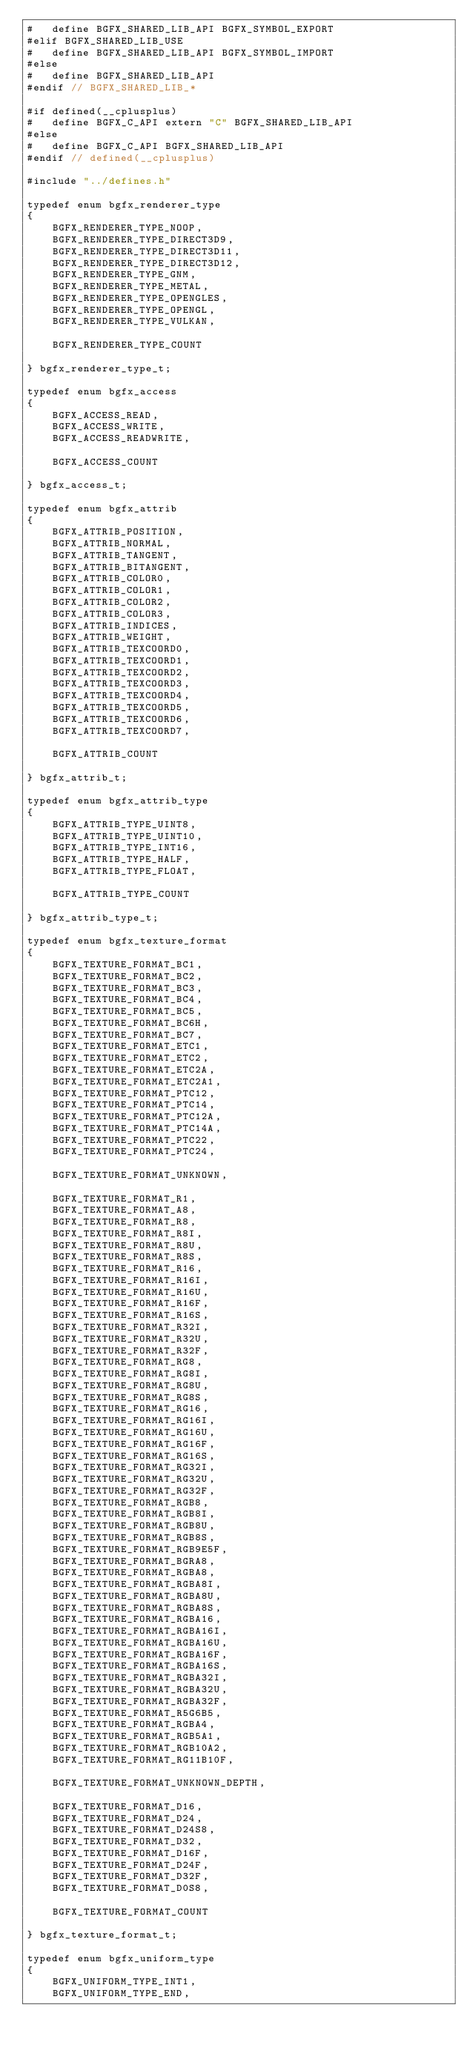Convert code to text. <code><loc_0><loc_0><loc_500><loc_500><_C_>#   define BGFX_SHARED_LIB_API BGFX_SYMBOL_EXPORT
#elif BGFX_SHARED_LIB_USE
#   define BGFX_SHARED_LIB_API BGFX_SYMBOL_IMPORT
#else
#   define BGFX_SHARED_LIB_API
#endif // BGFX_SHARED_LIB_*

#if defined(__cplusplus)
#   define BGFX_C_API extern "C" BGFX_SHARED_LIB_API
#else
#   define BGFX_C_API BGFX_SHARED_LIB_API
#endif // defined(__cplusplus)

#include "../defines.h"

typedef enum bgfx_renderer_type
{
    BGFX_RENDERER_TYPE_NOOP,
    BGFX_RENDERER_TYPE_DIRECT3D9,
    BGFX_RENDERER_TYPE_DIRECT3D11,
    BGFX_RENDERER_TYPE_DIRECT3D12,
    BGFX_RENDERER_TYPE_GNM,
    BGFX_RENDERER_TYPE_METAL,
    BGFX_RENDERER_TYPE_OPENGLES,
    BGFX_RENDERER_TYPE_OPENGL,
    BGFX_RENDERER_TYPE_VULKAN,

    BGFX_RENDERER_TYPE_COUNT

} bgfx_renderer_type_t;

typedef enum bgfx_access
{
    BGFX_ACCESS_READ,
    BGFX_ACCESS_WRITE,
    BGFX_ACCESS_READWRITE,

    BGFX_ACCESS_COUNT

} bgfx_access_t;

typedef enum bgfx_attrib
{
    BGFX_ATTRIB_POSITION,
    BGFX_ATTRIB_NORMAL,
    BGFX_ATTRIB_TANGENT,
    BGFX_ATTRIB_BITANGENT,
    BGFX_ATTRIB_COLOR0,
    BGFX_ATTRIB_COLOR1,
    BGFX_ATTRIB_COLOR2,
    BGFX_ATTRIB_COLOR3,
    BGFX_ATTRIB_INDICES,
    BGFX_ATTRIB_WEIGHT,
    BGFX_ATTRIB_TEXCOORD0,
    BGFX_ATTRIB_TEXCOORD1,
    BGFX_ATTRIB_TEXCOORD2,
    BGFX_ATTRIB_TEXCOORD3,
    BGFX_ATTRIB_TEXCOORD4,
    BGFX_ATTRIB_TEXCOORD5,
    BGFX_ATTRIB_TEXCOORD6,
    BGFX_ATTRIB_TEXCOORD7,

    BGFX_ATTRIB_COUNT

} bgfx_attrib_t;

typedef enum bgfx_attrib_type
{
    BGFX_ATTRIB_TYPE_UINT8,
    BGFX_ATTRIB_TYPE_UINT10,
    BGFX_ATTRIB_TYPE_INT16,
    BGFX_ATTRIB_TYPE_HALF,
    BGFX_ATTRIB_TYPE_FLOAT,

    BGFX_ATTRIB_TYPE_COUNT

} bgfx_attrib_type_t;

typedef enum bgfx_texture_format
{
    BGFX_TEXTURE_FORMAT_BC1,
    BGFX_TEXTURE_FORMAT_BC2,
    BGFX_TEXTURE_FORMAT_BC3,
    BGFX_TEXTURE_FORMAT_BC4,
    BGFX_TEXTURE_FORMAT_BC5,
    BGFX_TEXTURE_FORMAT_BC6H,
    BGFX_TEXTURE_FORMAT_BC7,
    BGFX_TEXTURE_FORMAT_ETC1,
    BGFX_TEXTURE_FORMAT_ETC2,
    BGFX_TEXTURE_FORMAT_ETC2A,
    BGFX_TEXTURE_FORMAT_ETC2A1,
    BGFX_TEXTURE_FORMAT_PTC12,
    BGFX_TEXTURE_FORMAT_PTC14,
    BGFX_TEXTURE_FORMAT_PTC12A,
    BGFX_TEXTURE_FORMAT_PTC14A,
    BGFX_TEXTURE_FORMAT_PTC22,
    BGFX_TEXTURE_FORMAT_PTC24,

    BGFX_TEXTURE_FORMAT_UNKNOWN,

    BGFX_TEXTURE_FORMAT_R1,
    BGFX_TEXTURE_FORMAT_A8,
    BGFX_TEXTURE_FORMAT_R8,
    BGFX_TEXTURE_FORMAT_R8I,
    BGFX_TEXTURE_FORMAT_R8U,
    BGFX_TEXTURE_FORMAT_R8S,
    BGFX_TEXTURE_FORMAT_R16,
    BGFX_TEXTURE_FORMAT_R16I,
    BGFX_TEXTURE_FORMAT_R16U,
    BGFX_TEXTURE_FORMAT_R16F,
    BGFX_TEXTURE_FORMAT_R16S,
    BGFX_TEXTURE_FORMAT_R32I,
    BGFX_TEXTURE_FORMAT_R32U,
    BGFX_TEXTURE_FORMAT_R32F,
    BGFX_TEXTURE_FORMAT_RG8,
    BGFX_TEXTURE_FORMAT_RG8I,
    BGFX_TEXTURE_FORMAT_RG8U,
    BGFX_TEXTURE_FORMAT_RG8S,
    BGFX_TEXTURE_FORMAT_RG16,
    BGFX_TEXTURE_FORMAT_RG16I,
    BGFX_TEXTURE_FORMAT_RG16U,
    BGFX_TEXTURE_FORMAT_RG16F,
    BGFX_TEXTURE_FORMAT_RG16S,
    BGFX_TEXTURE_FORMAT_RG32I,
    BGFX_TEXTURE_FORMAT_RG32U,
    BGFX_TEXTURE_FORMAT_RG32F,
    BGFX_TEXTURE_FORMAT_RGB8,
    BGFX_TEXTURE_FORMAT_RGB8I,
    BGFX_TEXTURE_FORMAT_RGB8U,
    BGFX_TEXTURE_FORMAT_RGB8S,
    BGFX_TEXTURE_FORMAT_RGB9E5F,
    BGFX_TEXTURE_FORMAT_BGRA8,
    BGFX_TEXTURE_FORMAT_RGBA8,
    BGFX_TEXTURE_FORMAT_RGBA8I,
    BGFX_TEXTURE_FORMAT_RGBA8U,
    BGFX_TEXTURE_FORMAT_RGBA8S,
    BGFX_TEXTURE_FORMAT_RGBA16,
    BGFX_TEXTURE_FORMAT_RGBA16I,
    BGFX_TEXTURE_FORMAT_RGBA16U,
    BGFX_TEXTURE_FORMAT_RGBA16F,
    BGFX_TEXTURE_FORMAT_RGBA16S,
    BGFX_TEXTURE_FORMAT_RGBA32I,
    BGFX_TEXTURE_FORMAT_RGBA32U,
    BGFX_TEXTURE_FORMAT_RGBA32F,
    BGFX_TEXTURE_FORMAT_R5G6B5,
    BGFX_TEXTURE_FORMAT_RGBA4,
    BGFX_TEXTURE_FORMAT_RGB5A1,
    BGFX_TEXTURE_FORMAT_RGB10A2,
    BGFX_TEXTURE_FORMAT_RG11B10F,

    BGFX_TEXTURE_FORMAT_UNKNOWN_DEPTH,

    BGFX_TEXTURE_FORMAT_D16,
    BGFX_TEXTURE_FORMAT_D24,
    BGFX_TEXTURE_FORMAT_D24S8,
    BGFX_TEXTURE_FORMAT_D32,
    BGFX_TEXTURE_FORMAT_D16F,
    BGFX_TEXTURE_FORMAT_D24F,
    BGFX_TEXTURE_FORMAT_D32F,
    BGFX_TEXTURE_FORMAT_D0S8,

    BGFX_TEXTURE_FORMAT_COUNT

} bgfx_texture_format_t;

typedef enum bgfx_uniform_type
{
    BGFX_UNIFORM_TYPE_INT1,
    BGFX_UNIFORM_TYPE_END,
</code> 